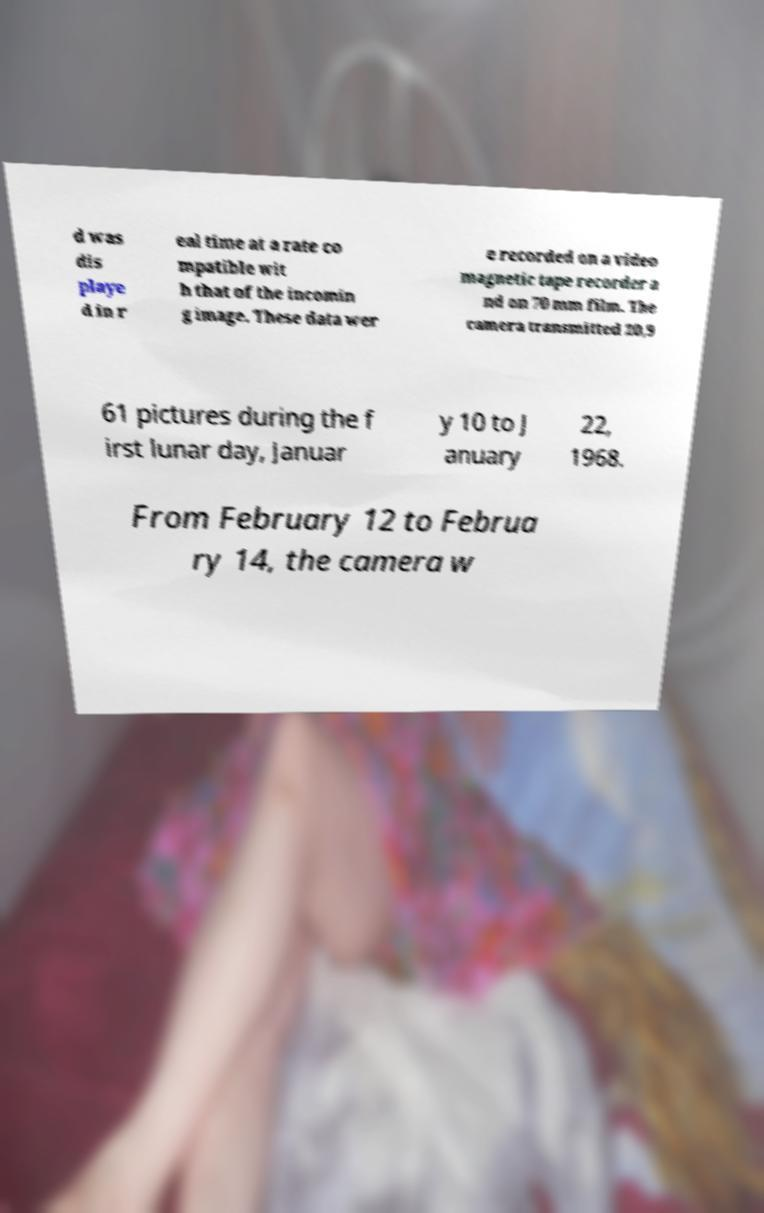What messages or text are displayed in this image? I need them in a readable, typed format. d was dis playe d in r eal time at a rate co mpatible wit h that of the incomin g image. These data wer e recorded on a video magnetic tape recorder a nd on 70 mm film. The camera transmitted 20,9 61 pictures during the f irst lunar day, Januar y 10 to J anuary 22, 1968. From February 12 to Februa ry 14, the camera w 